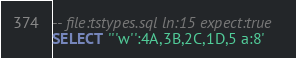Convert code to text. <code><loc_0><loc_0><loc_500><loc_500><_SQL_>-- file:tstypes.sql ln:15 expect:true
SELECT '''w'':4A,3B,2C,1D,5 a:8'
</code> 